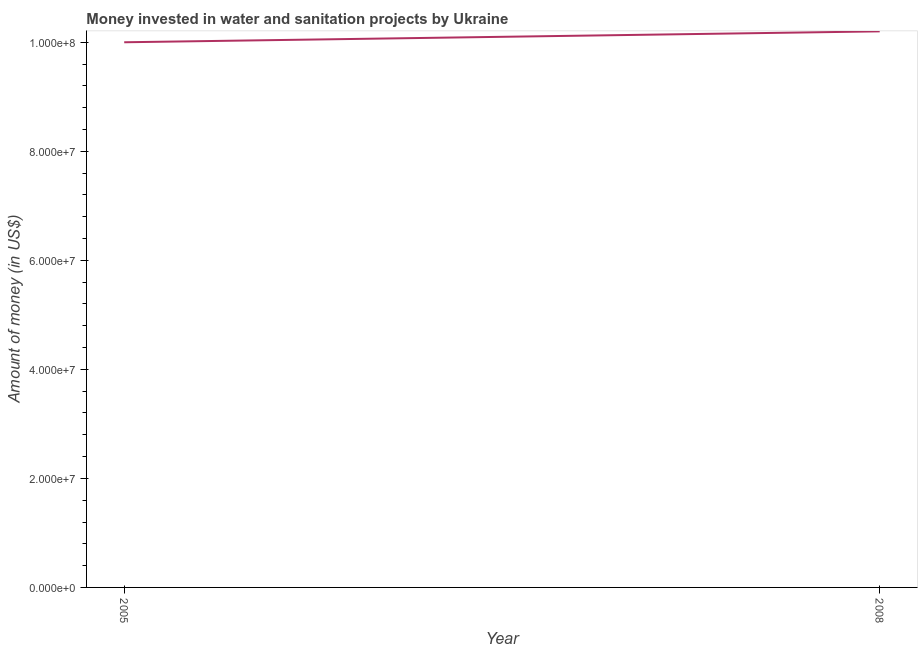What is the investment in 2008?
Give a very brief answer. 1.02e+08. Across all years, what is the maximum investment?
Provide a succinct answer. 1.02e+08. Across all years, what is the minimum investment?
Your answer should be very brief. 1.00e+08. In which year was the investment minimum?
Offer a terse response. 2005. What is the sum of the investment?
Keep it short and to the point. 2.02e+08. What is the difference between the investment in 2005 and 2008?
Your answer should be compact. -2.00e+06. What is the average investment per year?
Provide a succinct answer. 1.01e+08. What is the median investment?
Keep it short and to the point. 1.01e+08. In how many years, is the investment greater than 44000000 US$?
Give a very brief answer. 2. What is the ratio of the investment in 2005 to that in 2008?
Give a very brief answer. 0.98. Is the investment in 2005 less than that in 2008?
Ensure brevity in your answer.  Yes. In how many years, is the investment greater than the average investment taken over all years?
Your response must be concise. 1. How many lines are there?
Your response must be concise. 1. What is the title of the graph?
Your answer should be compact. Money invested in water and sanitation projects by Ukraine. What is the label or title of the X-axis?
Provide a short and direct response. Year. What is the label or title of the Y-axis?
Your answer should be very brief. Amount of money (in US$). What is the Amount of money (in US$) of 2008?
Ensure brevity in your answer.  1.02e+08. What is the ratio of the Amount of money (in US$) in 2005 to that in 2008?
Provide a succinct answer. 0.98. 